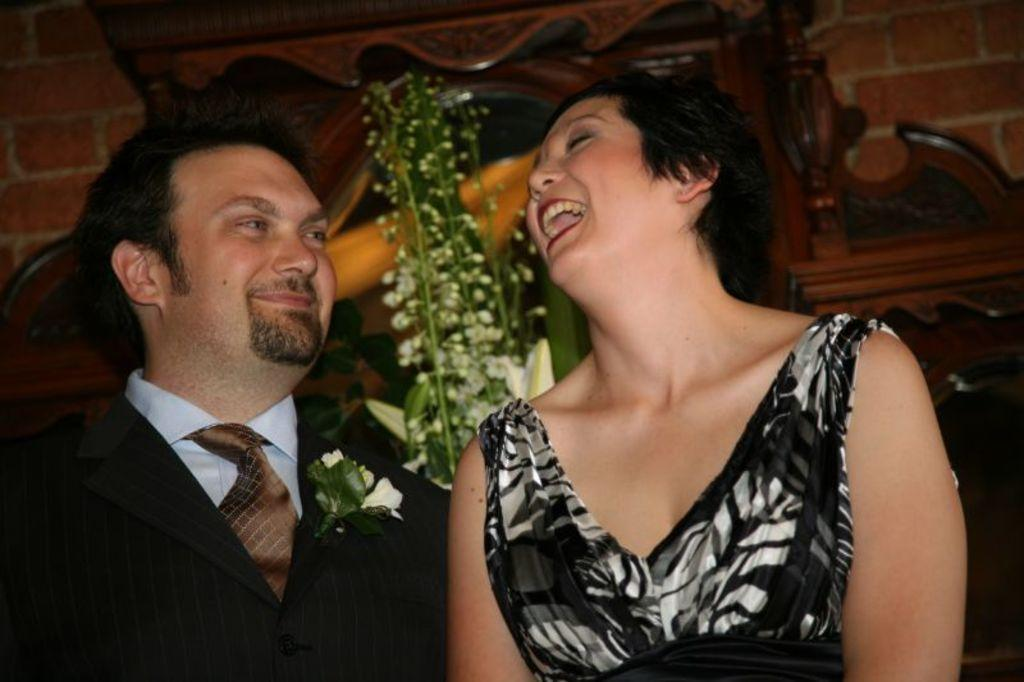What is the man in the image wearing? The man is wearing a black shirt. What is the woman in the image wearing? The woman is wearing a black dress. What expressions do the man and woman have in the image? Both the man and woman are smiling. What can be seen on the wall in the image? There is a flower vase on the wall. What language is the man speaking in the image? There is no indication of the man speaking in the image, so it cannot be determined what language he might be using. 